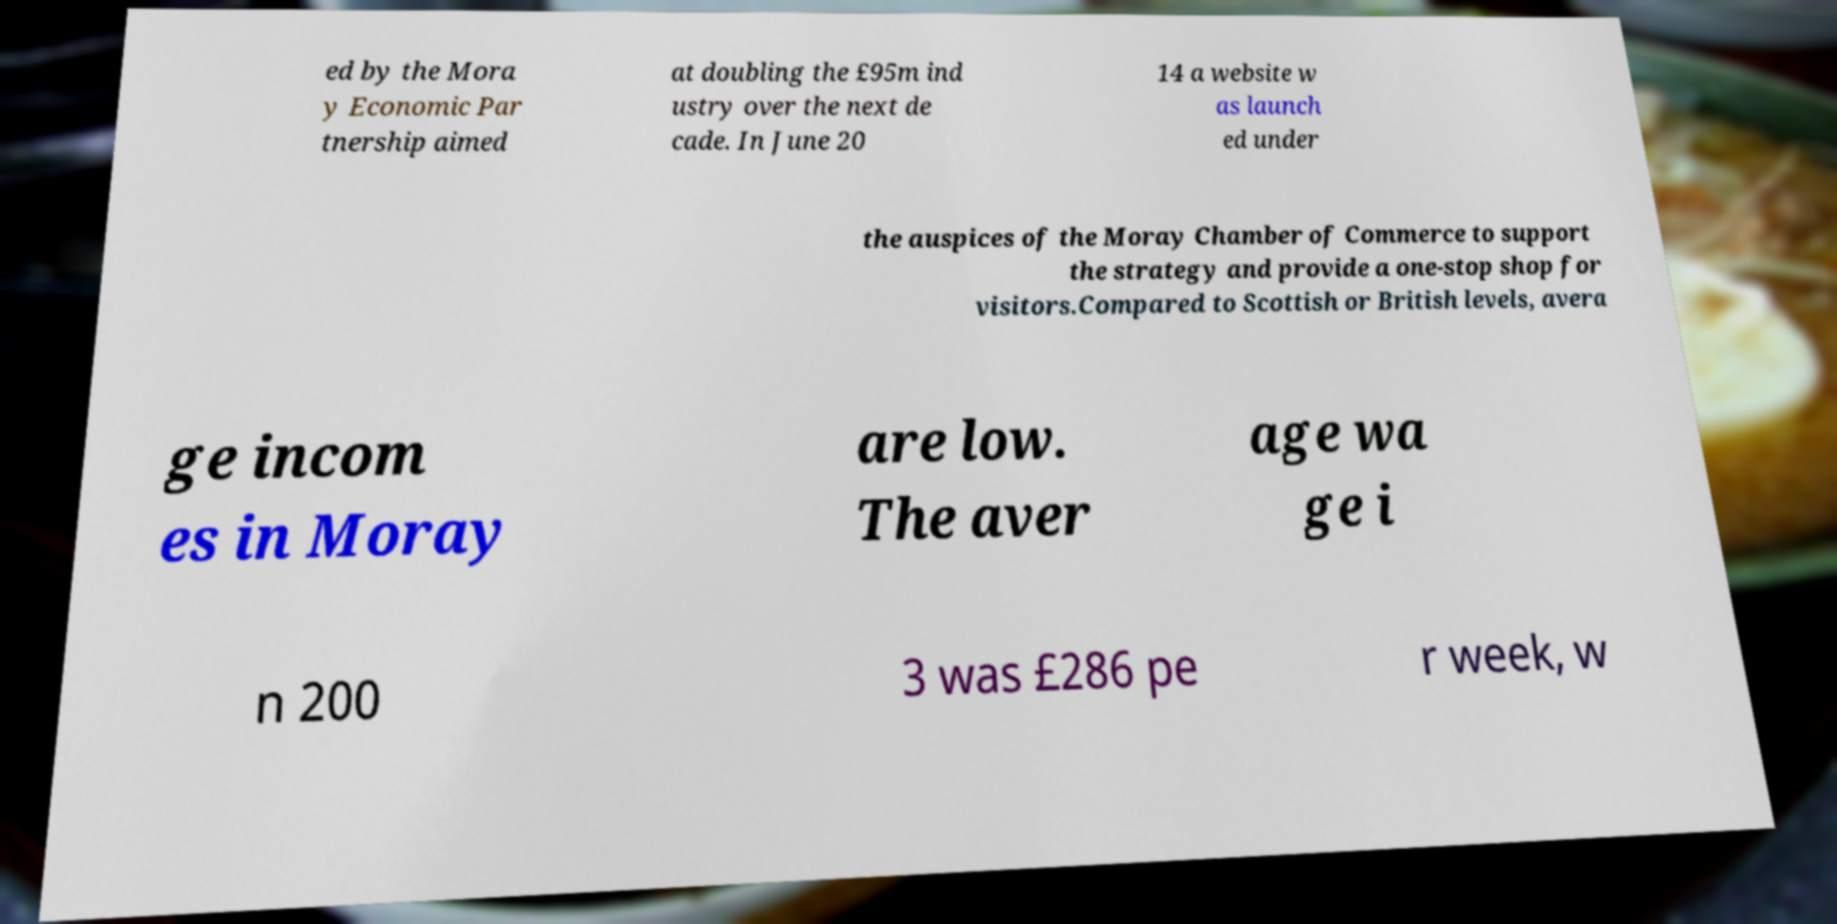Please identify and transcribe the text found in this image. ed by the Mora y Economic Par tnership aimed at doubling the £95m ind ustry over the next de cade. In June 20 14 a website w as launch ed under the auspices of the Moray Chamber of Commerce to support the strategy and provide a one-stop shop for visitors.Compared to Scottish or British levels, avera ge incom es in Moray are low. The aver age wa ge i n 200 3 was £286 pe r week, w 